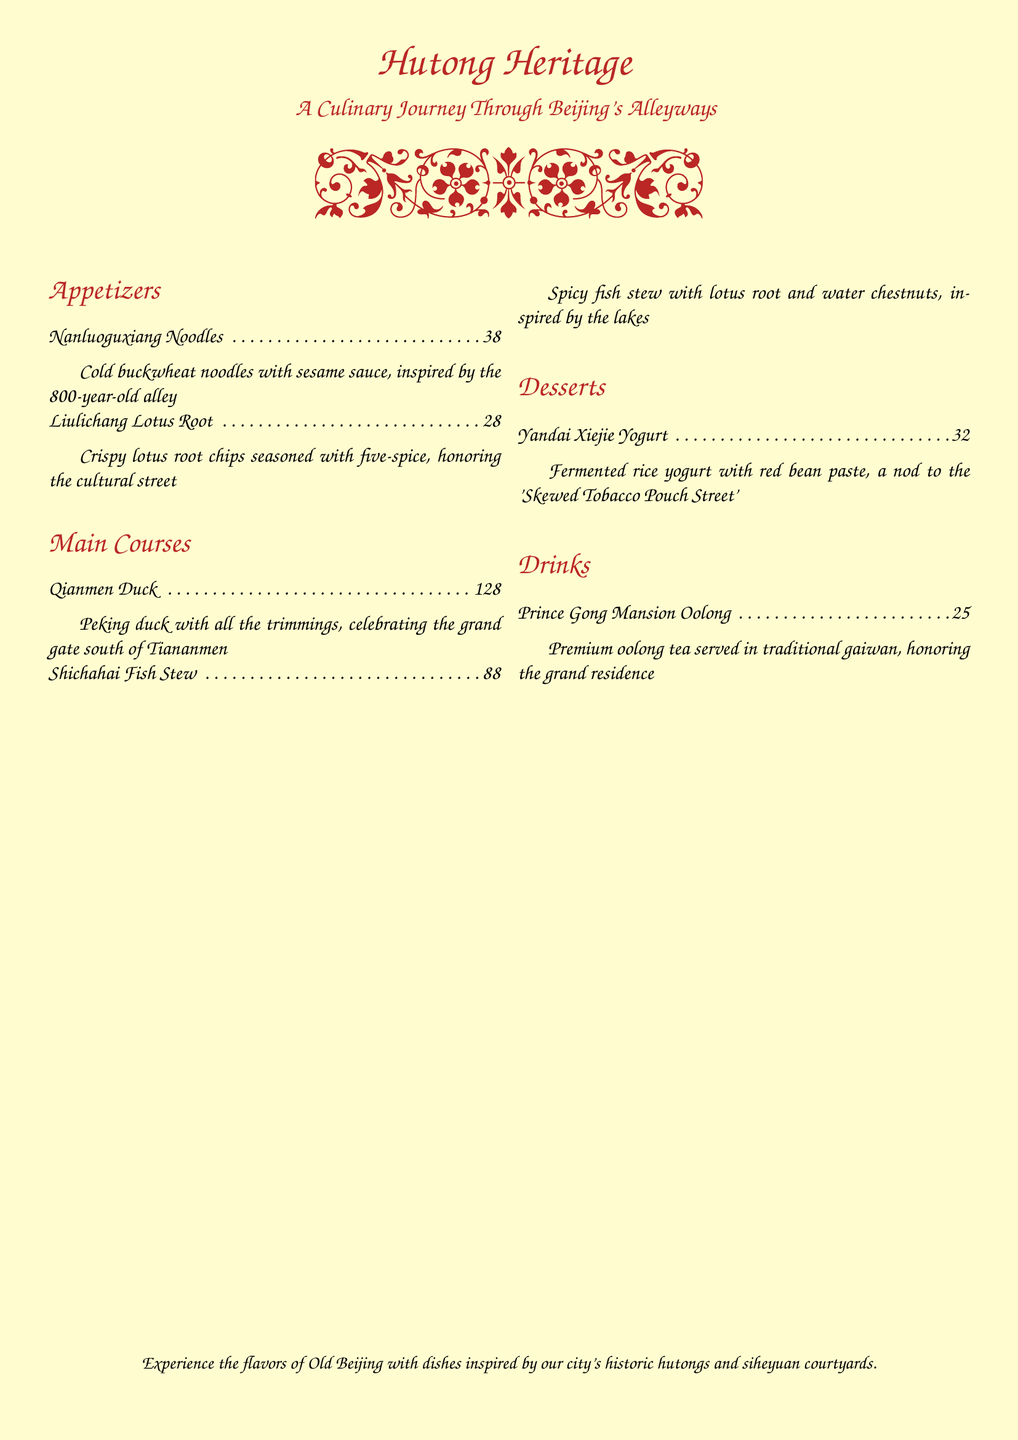what is the dish inspired by an 800-year-old alley? The dish is named after the famous alley, Nanluoguxiang, and is cold buckwheat noodles with sesame sauce.
Answer: Nanluoguxiang Noodles how much does the Qianmen Duck cost? The price for the Qianmen Duck on the menu is provided directly.
Answer: 128元 which appetizer is seasoned with five-spice? The dish that is crispy lotus root chips seasoned with five-spice is named after Liulichang.
Answer: Liulichang Lotus Root what is the price of Prince Gong Mansion Oolong? The menu specifies the price of this drink, allowing for a clear answer.
Answer: 25元 which dessert features red bean paste? The dessert that includes red bean paste is the fermented rice yogurt, associated with Yandai Xiejie.
Answer: Yandai Xiejie Yogurt what is the theme of this restaurant menu? The menu is themed around the alleyways and courtyard houses of Beijing.
Answer: Hutong Heritage what type of cuisine does this menu represent? Based on the dishes and their descriptions, this cuisine represents traditional Chinese food with a focus on Beijing's flavors.
Answer: Traditional Chinese how many main courses are listed on the menu? By counting the main courses section in the document, we find the total.
Answer: 2 what drink is served in a traditional gaiwan? The drink served in a tradiational gaiwan is identified in the drinks section.
Answer: Prince Gong Mansion Oolong 